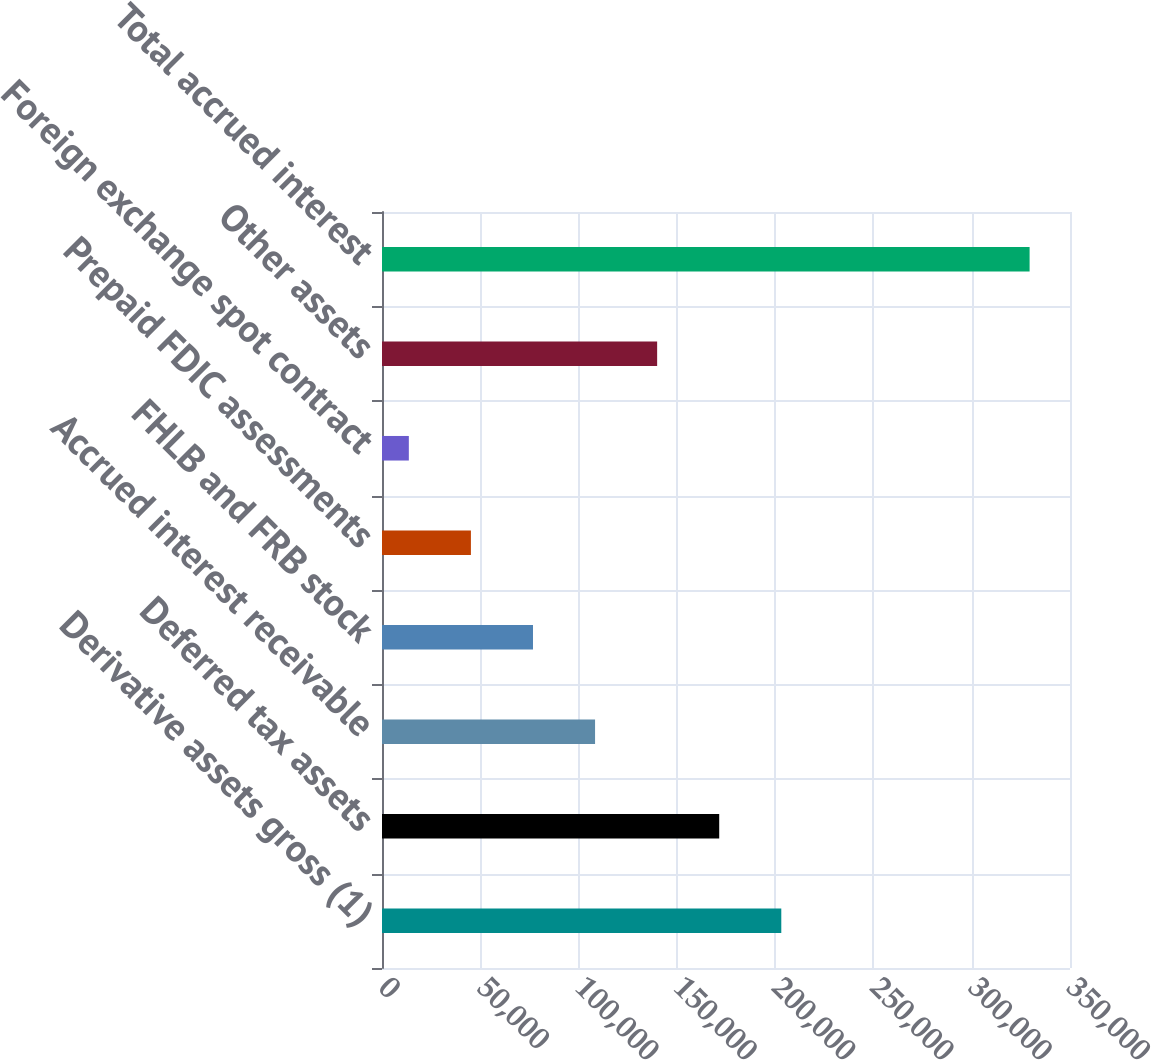<chart> <loc_0><loc_0><loc_500><loc_500><bar_chart><fcel>Derivative assets gross (1)<fcel>Deferred tax assets<fcel>Accrued interest receivable<fcel>FHLB and FRB stock<fcel>Prepaid FDIC assessments<fcel>Foreign exchange spot contract<fcel>Other assets<fcel>Total accrued interest<nl><fcel>203129<fcel>171550<fcel>108391<fcel>76811.8<fcel>45232.4<fcel>13653<fcel>139971<fcel>329447<nl></chart> 